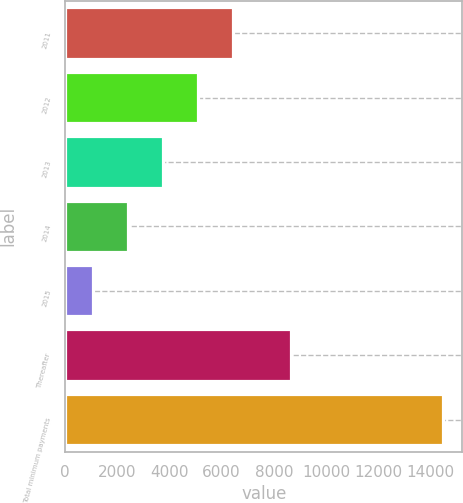Convert chart to OTSL. <chart><loc_0><loc_0><loc_500><loc_500><bar_chart><fcel>2011<fcel>2012<fcel>2013<fcel>2014<fcel>2015<fcel>Thereafter<fcel>Total minimum payments<nl><fcel>6448.1<fcel>5104.9<fcel>3761.7<fcel>2418.5<fcel>1075.3<fcel>8664.2<fcel>14507.3<nl></chart> 